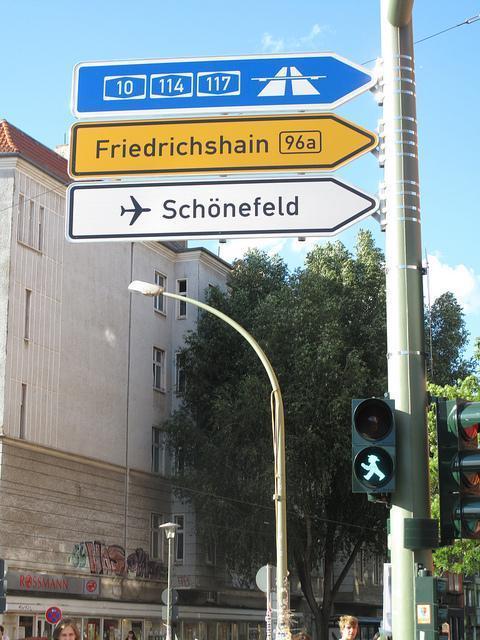How many signs do you see?
Give a very brief answer. 3. How many traffic lights are in the photo?
Give a very brief answer. 2. 